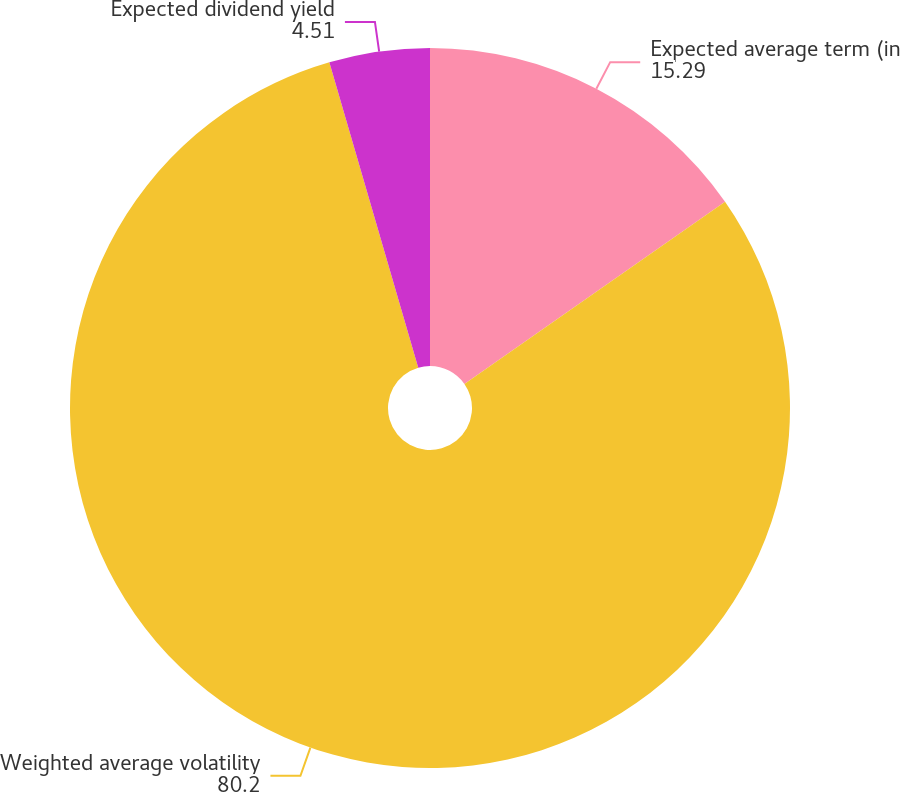<chart> <loc_0><loc_0><loc_500><loc_500><pie_chart><fcel>Expected average term (in<fcel>Weighted average volatility<fcel>Expected dividend yield<nl><fcel>15.29%<fcel>80.2%<fcel>4.51%<nl></chart> 